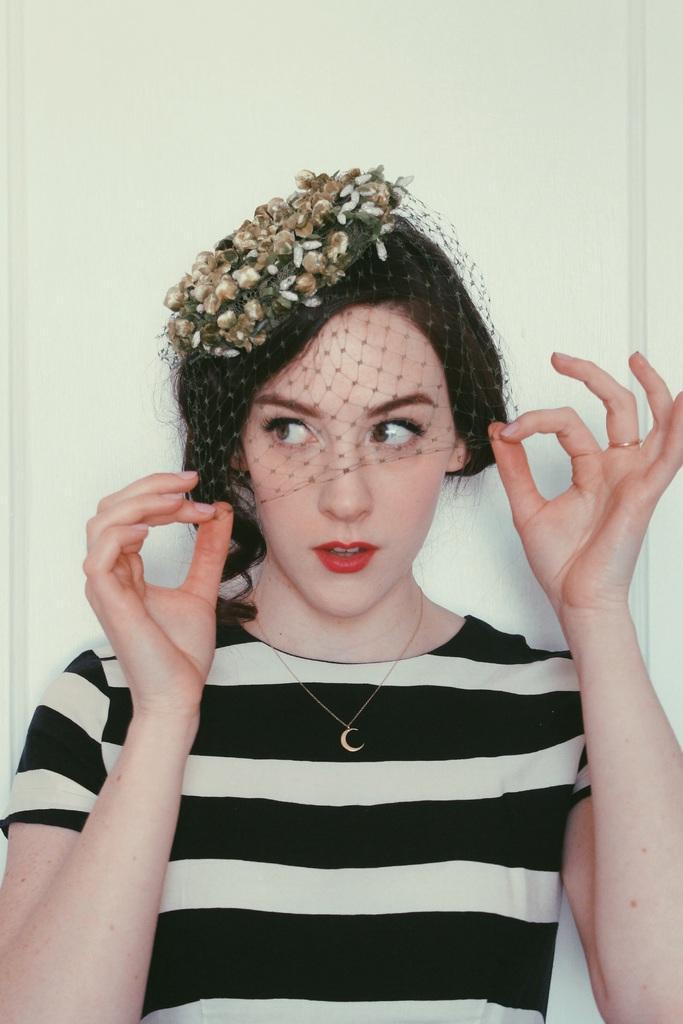Describe this image in one or two sentences. In this image in the center there is one woman who is wearing some hat, and in the background there is a wall. 